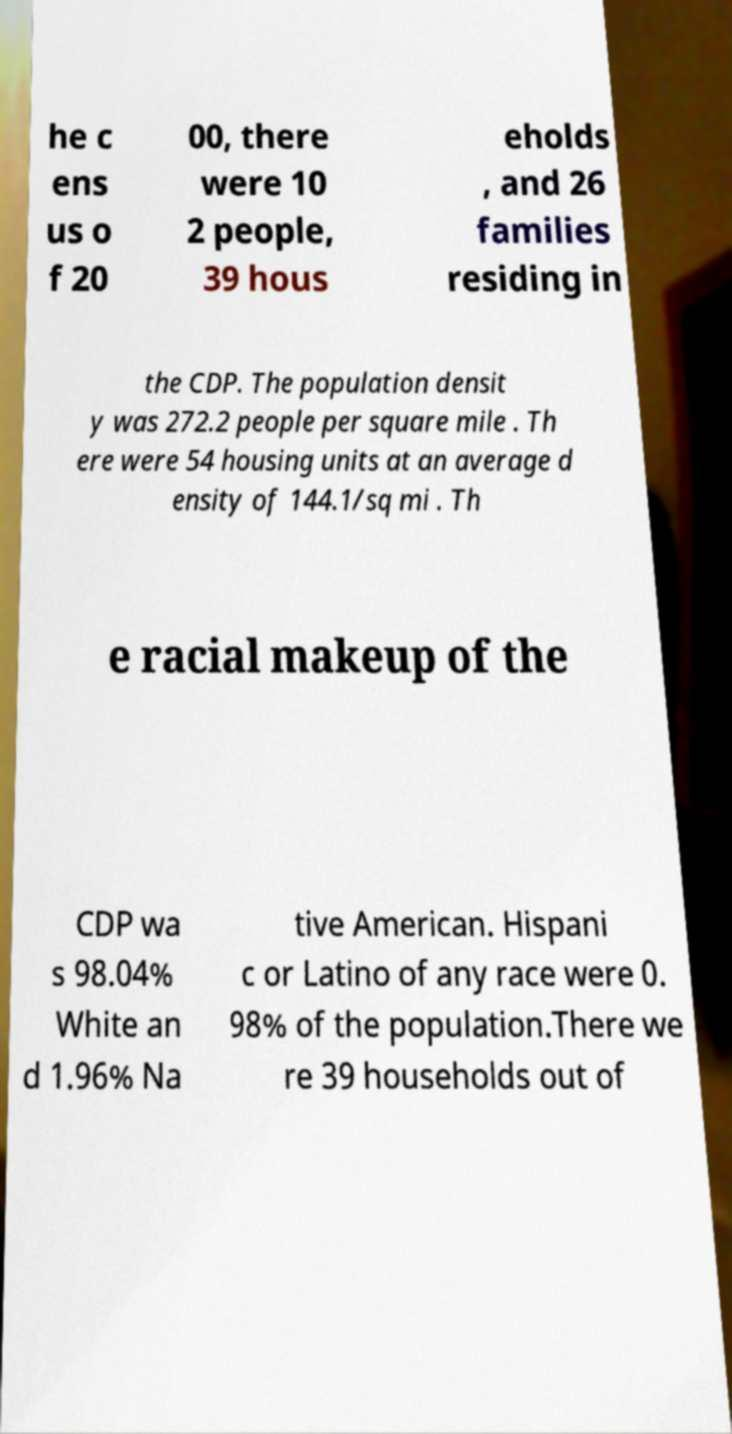Could you extract and type out the text from this image? he c ens us o f 20 00, there were 10 2 people, 39 hous eholds , and 26 families residing in the CDP. The population densit y was 272.2 people per square mile . Th ere were 54 housing units at an average d ensity of 144.1/sq mi . Th e racial makeup of the CDP wa s 98.04% White an d 1.96% Na tive American. Hispani c or Latino of any race were 0. 98% of the population.There we re 39 households out of 